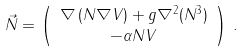<formula> <loc_0><loc_0><loc_500><loc_500>\vec { N } & = \left ( \begin{array} { c } \nabla \left ( N \nabla V \right ) + g \nabla ^ { 2 } ( N ^ { 3 } ) \\ - \alpha N V \end{array} \right ) \, .</formula> 